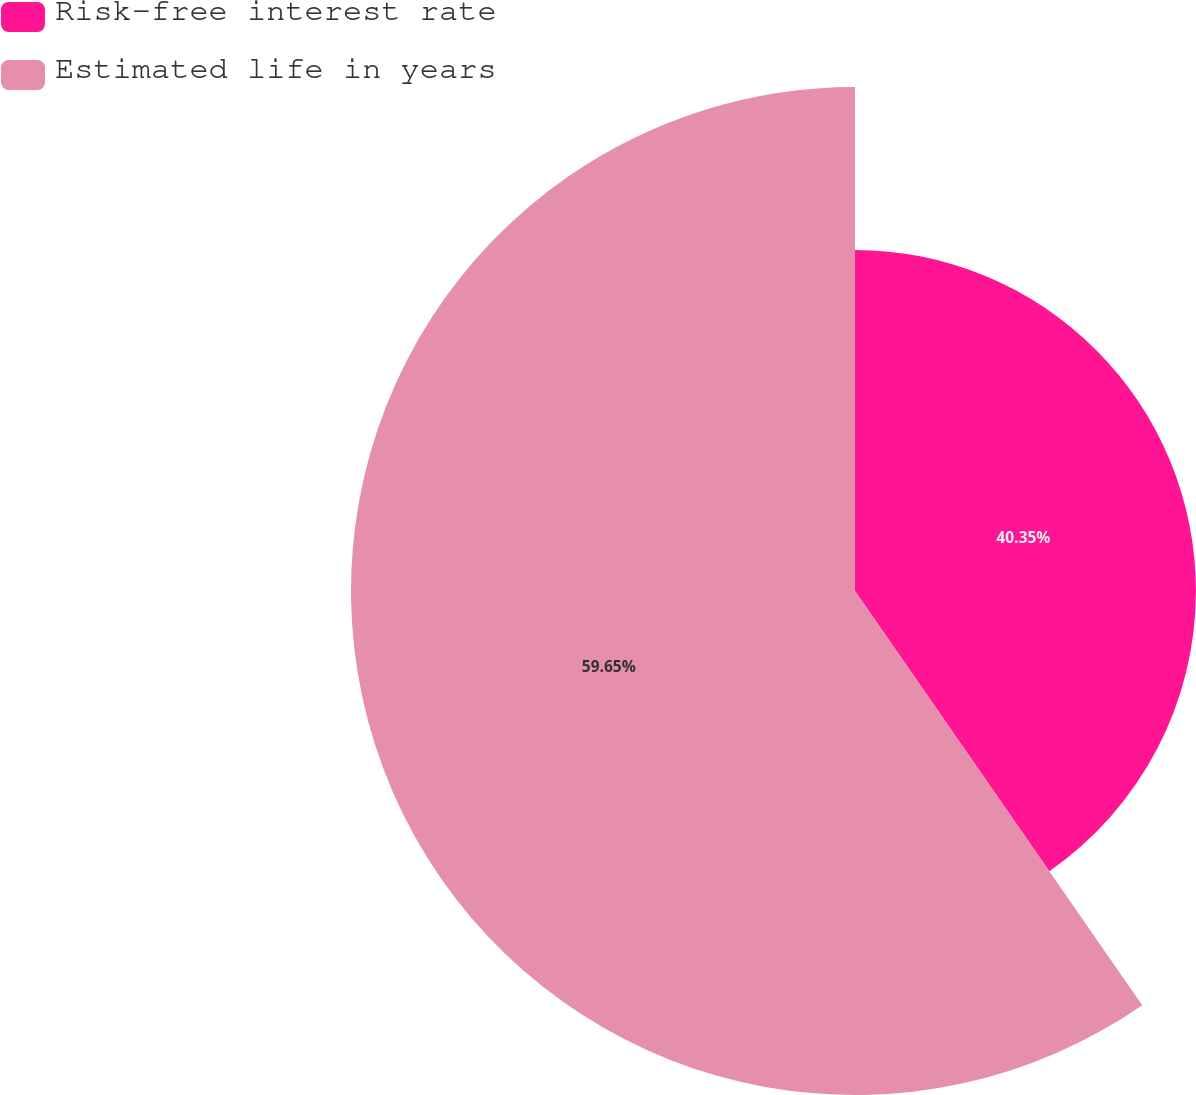Convert chart to OTSL. <chart><loc_0><loc_0><loc_500><loc_500><pie_chart><fcel>Risk-free interest rate<fcel>Estimated life in years<nl><fcel>40.35%<fcel>59.65%<nl></chart> 